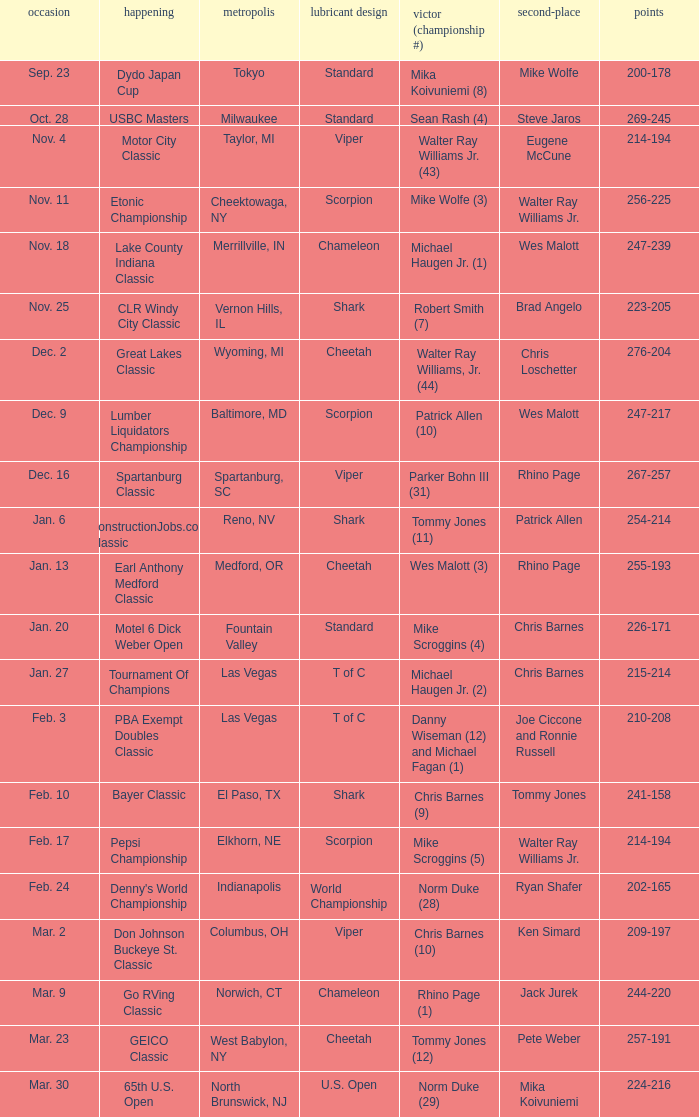Could you help me parse every detail presented in this table? {'header': ['occasion', 'happening', 'metropolis', 'lubricant design', 'victor (championship #)', 'second-place', 'points'], 'rows': [['Sep. 23', 'Dydo Japan Cup', 'Tokyo', 'Standard', 'Mika Koivuniemi (8)', 'Mike Wolfe', '200-178'], ['Oct. 28', 'USBC Masters', 'Milwaukee', 'Standard', 'Sean Rash (4)', 'Steve Jaros', '269-245'], ['Nov. 4', 'Motor City Classic', 'Taylor, MI', 'Viper', 'Walter Ray Williams Jr. (43)', 'Eugene McCune', '214-194'], ['Nov. 11', 'Etonic Championship', 'Cheektowaga, NY', 'Scorpion', 'Mike Wolfe (3)', 'Walter Ray Williams Jr.', '256-225'], ['Nov. 18', 'Lake County Indiana Classic', 'Merrillville, IN', 'Chameleon', 'Michael Haugen Jr. (1)', 'Wes Malott', '247-239'], ['Nov. 25', 'CLR Windy City Classic', 'Vernon Hills, IL', 'Shark', 'Robert Smith (7)', 'Brad Angelo', '223-205'], ['Dec. 2', 'Great Lakes Classic', 'Wyoming, MI', 'Cheetah', 'Walter Ray Williams, Jr. (44)', 'Chris Loschetter', '276-204'], ['Dec. 9', 'Lumber Liquidators Championship', 'Baltimore, MD', 'Scorpion', 'Patrick Allen (10)', 'Wes Malott', '247-217'], ['Dec. 16', 'Spartanburg Classic', 'Spartanburg, SC', 'Viper', 'Parker Bohn III (31)', 'Rhino Page', '267-257'], ['Jan. 6', 'ConstructionJobs.com Classic', 'Reno, NV', 'Shark', 'Tommy Jones (11)', 'Patrick Allen', '254-214'], ['Jan. 13', 'Earl Anthony Medford Classic', 'Medford, OR', 'Cheetah', 'Wes Malott (3)', 'Rhino Page', '255-193'], ['Jan. 20', 'Motel 6 Dick Weber Open', 'Fountain Valley', 'Standard', 'Mike Scroggins (4)', 'Chris Barnes', '226-171'], ['Jan. 27', 'Tournament Of Champions', 'Las Vegas', 'T of C', 'Michael Haugen Jr. (2)', 'Chris Barnes', '215-214'], ['Feb. 3', 'PBA Exempt Doubles Classic', 'Las Vegas', 'T of C', 'Danny Wiseman (12) and Michael Fagan (1)', 'Joe Ciccone and Ronnie Russell', '210-208'], ['Feb. 10', 'Bayer Classic', 'El Paso, TX', 'Shark', 'Chris Barnes (9)', 'Tommy Jones', '241-158'], ['Feb. 17', 'Pepsi Championship', 'Elkhorn, NE', 'Scorpion', 'Mike Scroggins (5)', 'Walter Ray Williams Jr.', '214-194'], ['Feb. 24', "Denny's World Championship", 'Indianapolis', 'World Championship', 'Norm Duke (28)', 'Ryan Shafer', '202-165'], ['Mar. 2', 'Don Johnson Buckeye St. Classic', 'Columbus, OH', 'Viper', 'Chris Barnes (10)', 'Ken Simard', '209-197'], ['Mar. 9', 'Go RVing Classic', 'Norwich, CT', 'Chameleon', 'Rhino Page (1)', 'Jack Jurek', '244-220'], ['Mar. 23', 'GEICO Classic', 'West Babylon, NY', 'Cheetah', 'Tommy Jones (12)', 'Pete Weber', '257-191'], ['Mar. 30', '65th U.S. Open', 'North Brunswick, NJ', 'U.S. Open', 'Norm Duke (29)', 'Mika Koivuniemi', '224-216']]} Name the Event which has a Winner (Title #) of parker bohn iii (31)? Spartanburg Classic. 